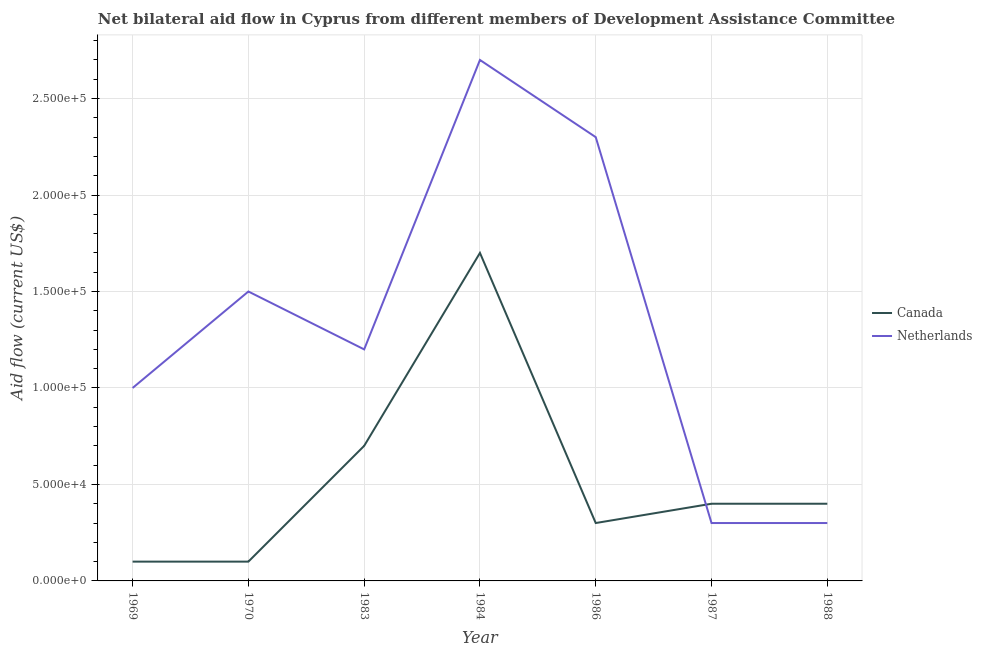Is the number of lines equal to the number of legend labels?
Make the answer very short. Yes. What is the amount of aid given by canada in 1984?
Ensure brevity in your answer.  1.70e+05. Across all years, what is the maximum amount of aid given by canada?
Keep it short and to the point. 1.70e+05. Across all years, what is the minimum amount of aid given by netherlands?
Your answer should be very brief. 3.00e+04. In which year was the amount of aid given by netherlands maximum?
Your response must be concise. 1984. In which year was the amount of aid given by netherlands minimum?
Your response must be concise. 1987. What is the total amount of aid given by netherlands in the graph?
Make the answer very short. 9.30e+05. What is the difference between the amount of aid given by canada in 1984 and that in 1986?
Offer a terse response. 1.40e+05. What is the difference between the amount of aid given by canada in 1988 and the amount of aid given by netherlands in 1970?
Your answer should be compact. -1.10e+05. What is the average amount of aid given by canada per year?
Your answer should be very brief. 5.29e+04. In the year 1986, what is the difference between the amount of aid given by netherlands and amount of aid given by canada?
Your response must be concise. 2.00e+05. What is the difference between the highest and the lowest amount of aid given by canada?
Keep it short and to the point. 1.60e+05. In how many years, is the amount of aid given by canada greater than the average amount of aid given by canada taken over all years?
Your answer should be very brief. 2. Does the amount of aid given by canada monotonically increase over the years?
Your answer should be very brief. No. What is the difference between two consecutive major ticks on the Y-axis?
Provide a succinct answer. 5.00e+04. Are the values on the major ticks of Y-axis written in scientific E-notation?
Keep it short and to the point. Yes. Does the graph contain any zero values?
Provide a succinct answer. No. Does the graph contain grids?
Offer a terse response. Yes. How many legend labels are there?
Offer a very short reply. 2. What is the title of the graph?
Give a very brief answer. Net bilateral aid flow in Cyprus from different members of Development Assistance Committee. What is the Aid flow (current US$) in Canada in 1969?
Your answer should be compact. 10000. What is the Aid flow (current US$) in Netherlands in 1970?
Offer a terse response. 1.50e+05. What is the Aid flow (current US$) in Canada in 1983?
Ensure brevity in your answer.  7.00e+04. What is the Aid flow (current US$) of Netherlands in 1986?
Ensure brevity in your answer.  2.30e+05. What is the Aid flow (current US$) of Canada in 1988?
Your answer should be compact. 4.00e+04. What is the total Aid flow (current US$) of Canada in the graph?
Offer a terse response. 3.70e+05. What is the total Aid flow (current US$) in Netherlands in the graph?
Provide a short and direct response. 9.30e+05. What is the difference between the Aid flow (current US$) of Netherlands in 1969 and that in 1970?
Your answer should be very brief. -5.00e+04. What is the difference between the Aid flow (current US$) in Canada in 1969 and that in 1983?
Your answer should be compact. -6.00e+04. What is the difference between the Aid flow (current US$) of Netherlands in 1969 and that in 1983?
Give a very brief answer. -2.00e+04. What is the difference between the Aid flow (current US$) of Canada in 1969 and that in 1984?
Offer a very short reply. -1.60e+05. What is the difference between the Aid flow (current US$) in Netherlands in 1969 and that in 1986?
Your answer should be very brief. -1.30e+05. What is the difference between the Aid flow (current US$) in Canada in 1969 and that in 1988?
Keep it short and to the point. -3.00e+04. What is the difference between the Aid flow (current US$) in Canada in 1970 and that in 1983?
Make the answer very short. -6.00e+04. What is the difference between the Aid flow (current US$) in Netherlands in 1970 and that in 1984?
Provide a succinct answer. -1.20e+05. What is the difference between the Aid flow (current US$) of Canada in 1970 and that in 1986?
Your answer should be very brief. -2.00e+04. What is the difference between the Aid flow (current US$) in Canada in 1970 and that in 1987?
Offer a very short reply. -3.00e+04. What is the difference between the Aid flow (current US$) of Netherlands in 1970 and that in 1987?
Make the answer very short. 1.20e+05. What is the difference between the Aid flow (current US$) in Canada in 1970 and that in 1988?
Keep it short and to the point. -3.00e+04. What is the difference between the Aid flow (current US$) of Netherlands in 1970 and that in 1988?
Provide a short and direct response. 1.20e+05. What is the difference between the Aid flow (current US$) in Canada in 1983 and that in 1984?
Offer a very short reply. -1.00e+05. What is the difference between the Aid flow (current US$) of Netherlands in 1983 and that in 1988?
Offer a very short reply. 9.00e+04. What is the difference between the Aid flow (current US$) of Netherlands in 1984 and that in 1986?
Offer a terse response. 4.00e+04. What is the difference between the Aid flow (current US$) in Netherlands in 1984 and that in 1987?
Give a very brief answer. 2.40e+05. What is the difference between the Aid flow (current US$) in Canada in 1984 and that in 1988?
Offer a very short reply. 1.30e+05. What is the difference between the Aid flow (current US$) in Netherlands in 1984 and that in 1988?
Keep it short and to the point. 2.40e+05. What is the difference between the Aid flow (current US$) of Netherlands in 1986 and that in 1987?
Provide a succinct answer. 2.00e+05. What is the difference between the Aid flow (current US$) in Canada in 1986 and that in 1988?
Your answer should be very brief. -10000. What is the difference between the Aid flow (current US$) in Netherlands in 1987 and that in 1988?
Your response must be concise. 0. What is the difference between the Aid flow (current US$) of Canada in 1969 and the Aid flow (current US$) of Netherlands in 1970?
Give a very brief answer. -1.40e+05. What is the difference between the Aid flow (current US$) of Canada in 1969 and the Aid flow (current US$) of Netherlands in 1984?
Give a very brief answer. -2.60e+05. What is the difference between the Aid flow (current US$) in Canada in 1969 and the Aid flow (current US$) in Netherlands in 1986?
Keep it short and to the point. -2.20e+05. What is the difference between the Aid flow (current US$) of Canada in 1983 and the Aid flow (current US$) of Netherlands in 1984?
Give a very brief answer. -2.00e+05. What is the difference between the Aid flow (current US$) in Canada in 1983 and the Aid flow (current US$) in Netherlands in 1986?
Ensure brevity in your answer.  -1.60e+05. What is the difference between the Aid flow (current US$) of Canada in 1983 and the Aid flow (current US$) of Netherlands in 1987?
Your response must be concise. 4.00e+04. What is the difference between the Aid flow (current US$) of Canada in 1983 and the Aid flow (current US$) of Netherlands in 1988?
Ensure brevity in your answer.  4.00e+04. What is the difference between the Aid flow (current US$) in Canada in 1984 and the Aid flow (current US$) in Netherlands in 1987?
Your answer should be very brief. 1.40e+05. What is the difference between the Aid flow (current US$) in Canada in 1984 and the Aid flow (current US$) in Netherlands in 1988?
Your answer should be very brief. 1.40e+05. What is the difference between the Aid flow (current US$) in Canada in 1986 and the Aid flow (current US$) in Netherlands in 1988?
Your response must be concise. 0. What is the difference between the Aid flow (current US$) of Canada in 1987 and the Aid flow (current US$) of Netherlands in 1988?
Keep it short and to the point. 10000. What is the average Aid flow (current US$) of Canada per year?
Keep it short and to the point. 5.29e+04. What is the average Aid flow (current US$) in Netherlands per year?
Your answer should be very brief. 1.33e+05. In the year 1983, what is the difference between the Aid flow (current US$) in Canada and Aid flow (current US$) in Netherlands?
Provide a short and direct response. -5.00e+04. In the year 1986, what is the difference between the Aid flow (current US$) in Canada and Aid flow (current US$) in Netherlands?
Your answer should be compact. -2.00e+05. In the year 1987, what is the difference between the Aid flow (current US$) of Canada and Aid flow (current US$) of Netherlands?
Make the answer very short. 10000. In the year 1988, what is the difference between the Aid flow (current US$) of Canada and Aid flow (current US$) of Netherlands?
Make the answer very short. 10000. What is the ratio of the Aid flow (current US$) in Canada in 1969 to that in 1970?
Your answer should be very brief. 1. What is the ratio of the Aid flow (current US$) in Canada in 1969 to that in 1983?
Give a very brief answer. 0.14. What is the ratio of the Aid flow (current US$) in Netherlands in 1969 to that in 1983?
Ensure brevity in your answer.  0.83. What is the ratio of the Aid flow (current US$) in Canada in 1969 to that in 1984?
Offer a terse response. 0.06. What is the ratio of the Aid flow (current US$) of Netherlands in 1969 to that in 1984?
Give a very brief answer. 0.37. What is the ratio of the Aid flow (current US$) in Canada in 1969 to that in 1986?
Provide a short and direct response. 0.33. What is the ratio of the Aid flow (current US$) in Netherlands in 1969 to that in 1986?
Provide a short and direct response. 0.43. What is the ratio of the Aid flow (current US$) in Canada in 1969 to that in 1987?
Your answer should be compact. 0.25. What is the ratio of the Aid flow (current US$) of Canada in 1969 to that in 1988?
Give a very brief answer. 0.25. What is the ratio of the Aid flow (current US$) of Canada in 1970 to that in 1983?
Provide a short and direct response. 0.14. What is the ratio of the Aid flow (current US$) of Netherlands in 1970 to that in 1983?
Your response must be concise. 1.25. What is the ratio of the Aid flow (current US$) in Canada in 1970 to that in 1984?
Give a very brief answer. 0.06. What is the ratio of the Aid flow (current US$) in Netherlands in 1970 to that in 1984?
Make the answer very short. 0.56. What is the ratio of the Aid flow (current US$) in Netherlands in 1970 to that in 1986?
Keep it short and to the point. 0.65. What is the ratio of the Aid flow (current US$) in Canada in 1970 to that in 1988?
Make the answer very short. 0.25. What is the ratio of the Aid flow (current US$) of Canada in 1983 to that in 1984?
Provide a short and direct response. 0.41. What is the ratio of the Aid flow (current US$) of Netherlands in 1983 to that in 1984?
Give a very brief answer. 0.44. What is the ratio of the Aid flow (current US$) of Canada in 1983 to that in 1986?
Ensure brevity in your answer.  2.33. What is the ratio of the Aid flow (current US$) in Netherlands in 1983 to that in 1986?
Give a very brief answer. 0.52. What is the ratio of the Aid flow (current US$) of Canada in 1983 to that in 1987?
Ensure brevity in your answer.  1.75. What is the ratio of the Aid flow (current US$) of Netherlands in 1983 to that in 1987?
Your answer should be compact. 4. What is the ratio of the Aid flow (current US$) of Canada in 1983 to that in 1988?
Make the answer very short. 1.75. What is the ratio of the Aid flow (current US$) in Netherlands in 1983 to that in 1988?
Provide a succinct answer. 4. What is the ratio of the Aid flow (current US$) in Canada in 1984 to that in 1986?
Keep it short and to the point. 5.67. What is the ratio of the Aid flow (current US$) in Netherlands in 1984 to that in 1986?
Your answer should be very brief. 1.17. What is the ratio of the Aid flow (current US$) of Canada in 1984 to that in 1987?
Your answer should be compact. 4.25. What is the ratio of the Aid flow (current US$) in Canada in 1984 to that in 1988?
Give a very brief answer. 4.25. What is the ratio of the Aid flow (current US$) of Canada in 1986 to that in 1987?
Your answer should be very brief. 0.75. What is the ratio of the Aid flow (current US$) of Netherlands in 1986 to that in 1987?
Your answer should be compact. 7.67. What is the ratio of the Aid flow (current US$) in Canada in 1986 to that in 1988?
Your answer should be very brief. 0.75. What is the ratio of the Aid flow (current US$) in Netherlands in 1986 to that in 1988?
Ensure brevity in your answer.  7.67. What is the difference between the highest and the lowest Aid flow (current US$) of Netherlands?
Provide a short and direct response. 2.40e+05. 